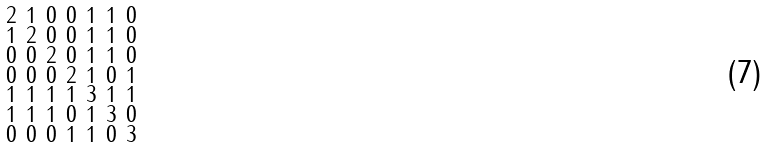Convert formula to latex. <formula><loc_0><loc_0><loc_500><loc_500>\begin{smallmatrix} 2 & 1 & 0 & 0 & 1 & 1 & 0 \\ 1 & 2 & 0 & 0 & 1 & 1 & 0 \\ 0 & 0 & 2 & 0 & 1 & 1 & 0 \\ 0 & 0 & 0 & 2 & 1 & 0 & 1 \\ 1 & 1 & 1 & 1 & 3 & 1 & 1 \\ 1 & 1 & 1 & 0 & 1 & 3 & 0 \\ 0 & 0 & 0 & 1 & 1 & 0 & 3 \end{smallmatrix}</formula> 